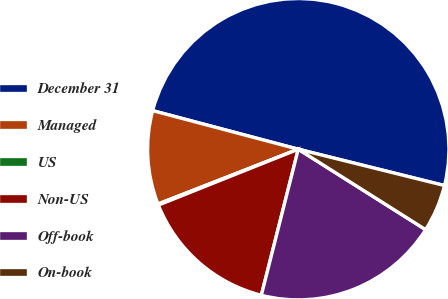<chart> <loc_0><loc_0><loc_500><loc_500><pie_chart><fcel>December 31<fcel>Managed<fcel>US<fcel>Non-US<fcel>Off-book<fcel>On-book<nl><fcel>49.76%<fcel>10.05%<fcel>0.12%<fcel>15.01%<fcel>19.98%<fcel>5.09%<nl></chart> 